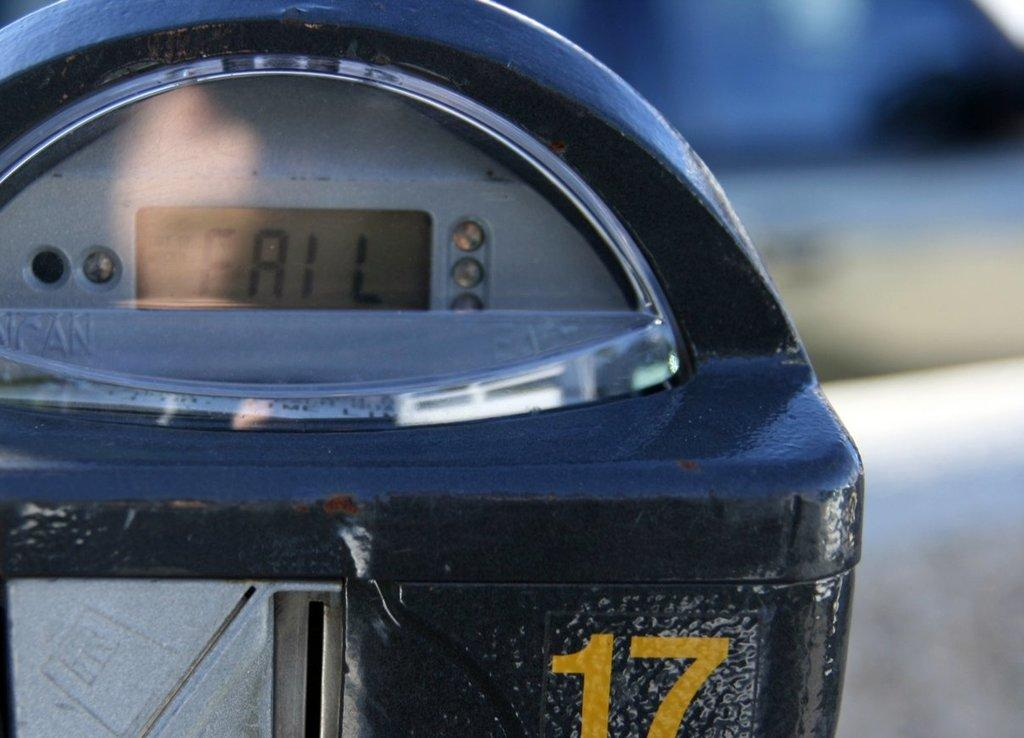<image>
Describe the image concisely. Parking meter 17 displays a fail message on it. 